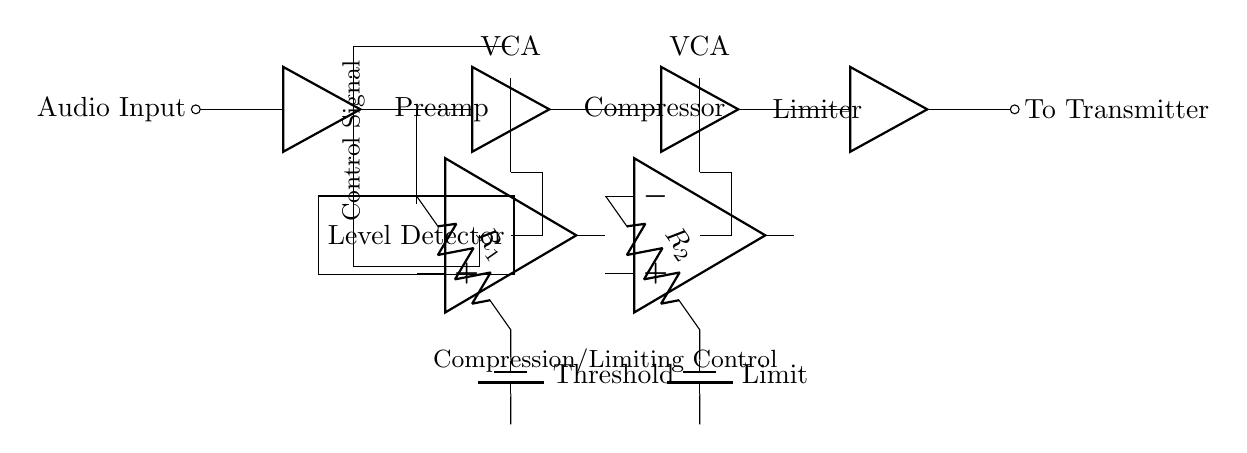What is the function of the first amplifier in the circuit? The first amplifier is labeled as "Preamp," indicating it serves to amplify the audio signal before further processing. This step boosts the weak audio signal to a more manageable level for compression.
Answer: Preamp How many voltage-controlled amplifiers are present in the circuit? The circuit diagram shows two voltage-controlled amplifiers, both labeled as "VCA," positioned after the compressor and limiter stages. Each VCA operates under the control of a specific signal.
Answer: Two What does the term "Threshold" in the circuit refer to? "Threshold" refers to the setting that determines the level at which the compressor starts to reduce the audio signal's gain. The circuit features a potentiometer controlled by a resistor to set this level.
Answer: Level for compression What type of circuit is this primarily categorized as? This circuit is categorized as an audio processing circuit, specifically designed for compression and limiting, ensuring consistent broadcast volume by controlling dynamic range.
Answer: Audio processing Explain the purpose of the "Level Detector" in the circuit. The "Level Detector" monitors the input audio signal's amplitude and sends the detected level to the compressor and limiter to adjust their gain based on the incoming signal strength. This helps maintain a steady output level.
Answer: Signal monitoring 